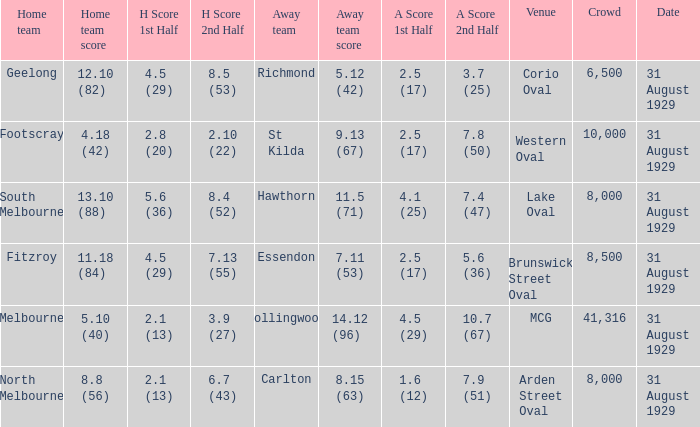What was the score of the home team when the away team scored 14.12 (96)? 5.10 (40). 